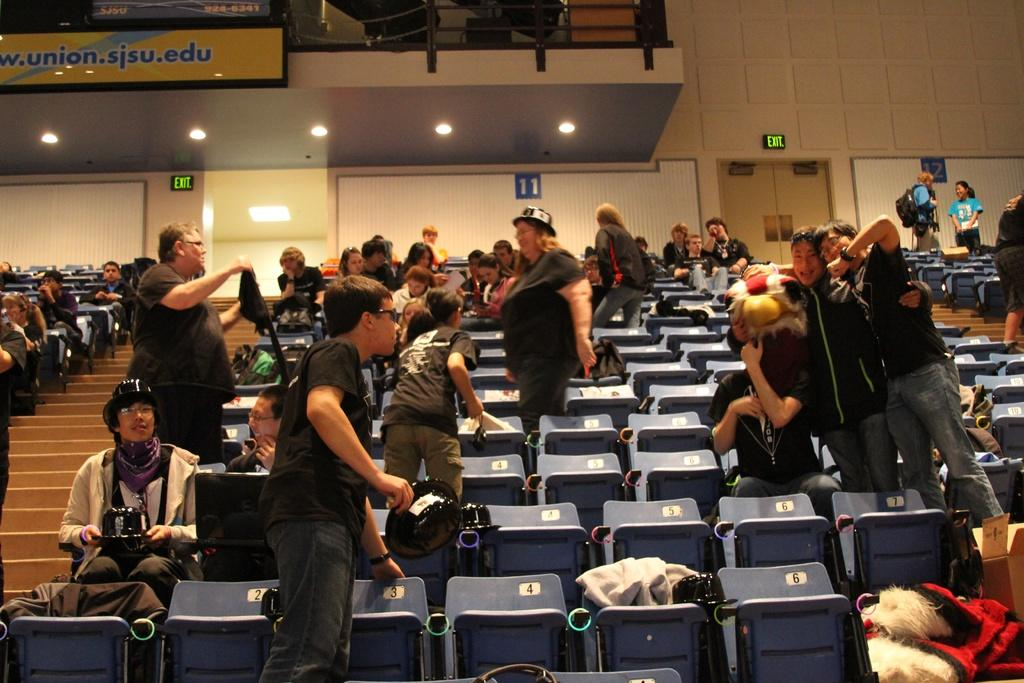What are the people in the image doing? There are people sitting on chairs and standing in the image. What can be seen in the background of the image? There is a wall and a roof in the background of the image. How many lizards can be seen climbing the wall in the image? There are no lizards visible in the image. What route are the people taking in the image? The image does not provide information about a specific route or direction the people are taking. 